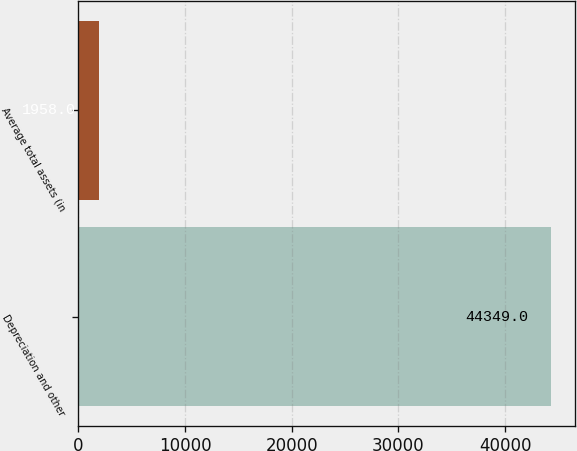Convert chart. <chart><loc_0><loc_0><loc_500><loc_500><bar_chart><fcel>Depreciation and other<fcel>Average total assets (in<nl><fcel>44349<fcel>1958<nl></chart> 